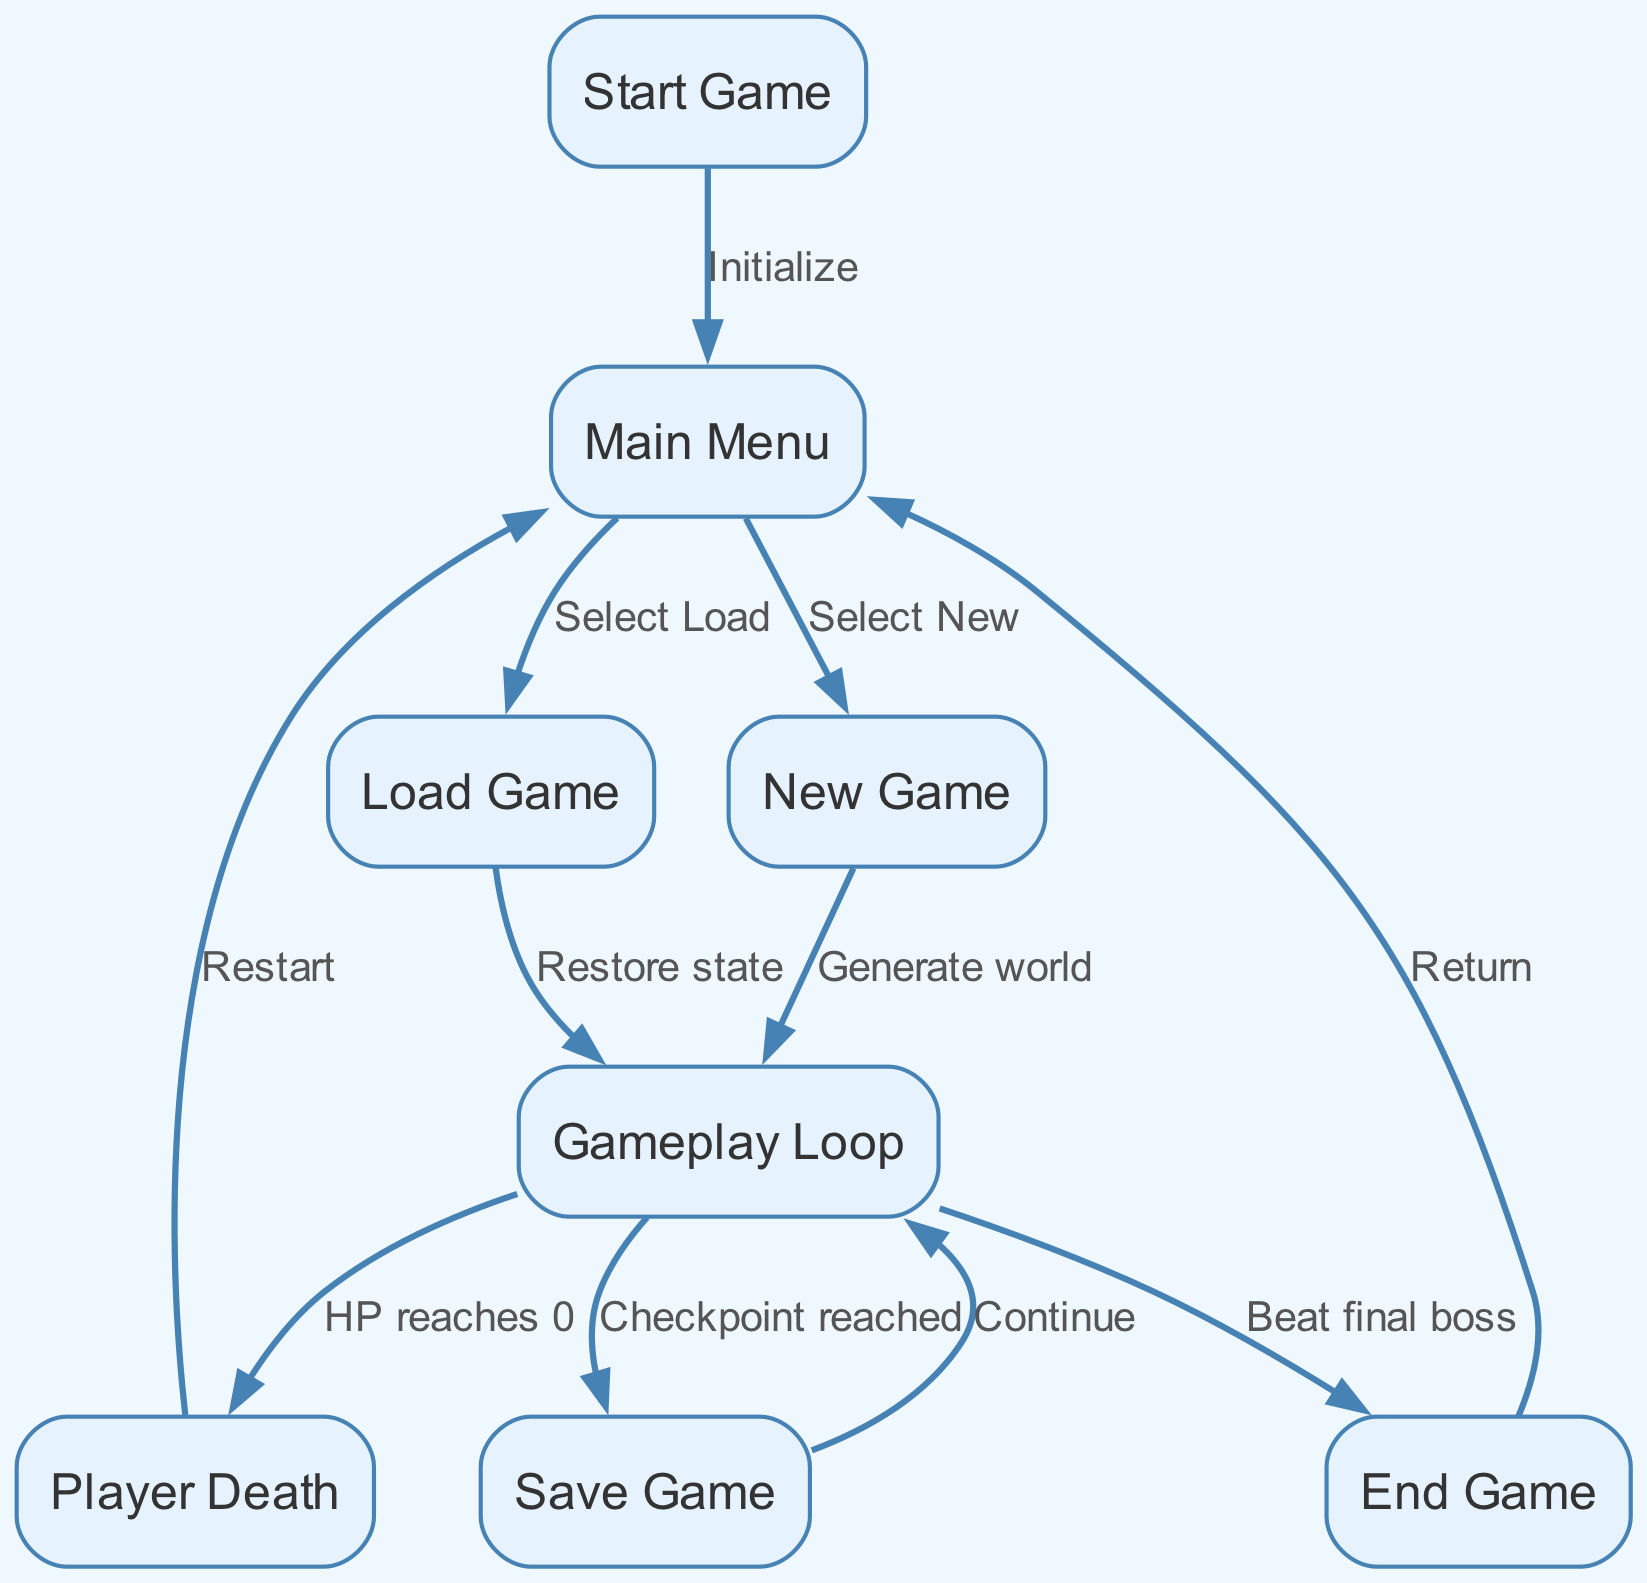What is the first node in the flowchart? The first node in the flowchart is labeled "Start Game." It indicates the beginning of the process for game save and load functionality. The information can be obtained by looking at the node labeled "start."
Answer: Start Game How many edges are present in the diagram? By counting each connection from one node to another, we find there are ten edges that illustrate the relationships between the nodes in the flowchart.
Answer: 10 What happens when the player selects "Load Game"? The edge from the "Load Game" node leads to the "Gameplay Loop" node, indicating that selecting this option will restore the previous game state and enter the gameplay phase.
Answer: Restore state What is the outcome of the player reaching 0 HP during the gameplay? When the player's HP reaches 0, the flowchart indicates a transition to the "Player Death" node, which signifies that the player has died in the game.
Answer: Player Death What action occurs after reaching a checkpoint in gameplay? After reaching a checkpoint during gameplay, the flow leads to the "Save Game" node, where the player's progress can be saved. This indicates a pause or save opportunity during the game.
Answer: Save Game What are the two possible options in the main menu? The main menu provides two options: "Load Game" and "New Game." These options determine how the player will proceed in their gaming session.
Answer: Load Game, New Game What happens if the player successfully beats the final boss? Upon defeating the final boss, the flowchart directs to the "End Game" node, which signifies the conclusion of the game session and the transition towards the main menu.
Answer: End Game What is the common action that occurs when the game reaches the end? The common action that occurs when the game reaches the end is to "Return" to the main menu, suggesting options for replaying or accessing other features.
Answer: Return 